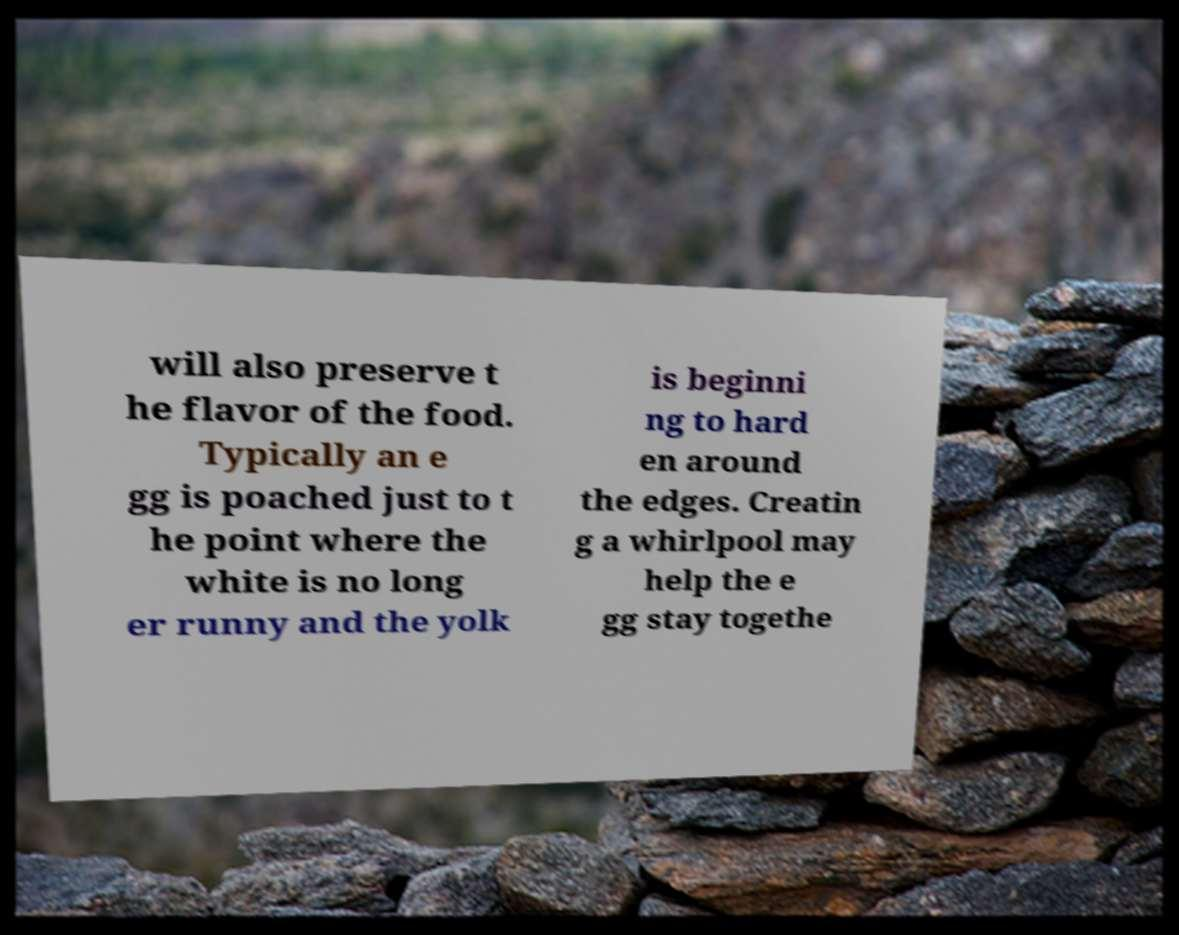Please identify and transcribe the text found in this image. will also preserve t he flavor of the food. Typically an e gg is poached just to t he point where the white is no long er runny and the yolk is beginni ng to hard en around the edges. Creatin g a whirlpool may help the e gg stay togethe 